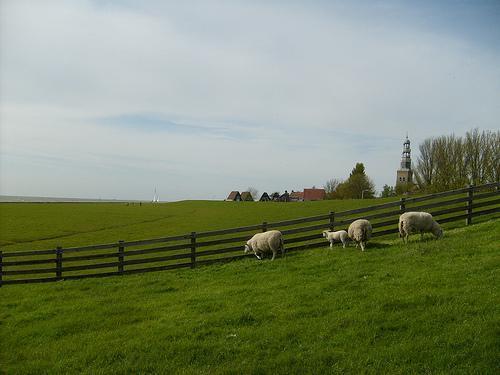How many sheep are there?
Give a very brief answer. 4. How many sheep are visible?
Give a very brief answer. 4. 